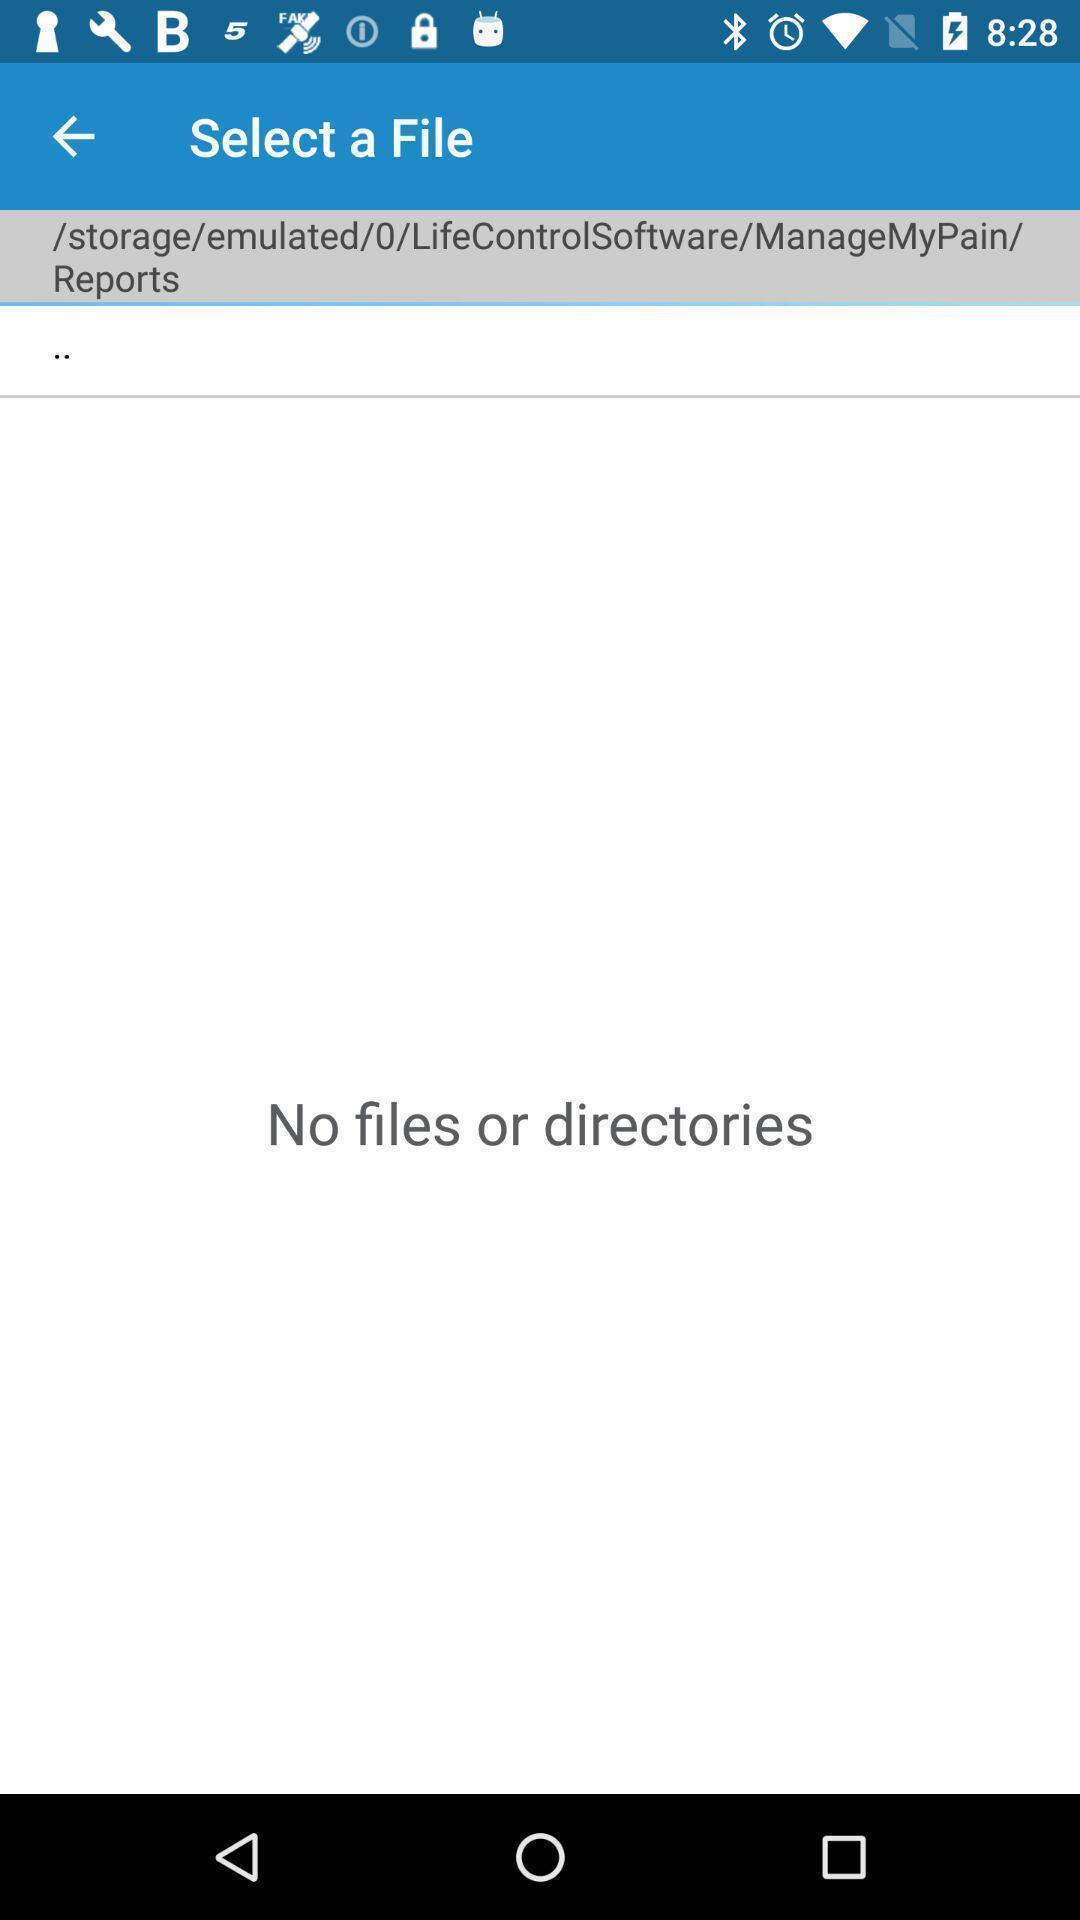What is the overall content of this screenshot? Screen showing no files. 